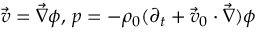Convert formula to latex. <formula><loc_0><loc_0><loc_500><loc_500>\vec { v } = \vec { \nabla } \phi , \, p = - \rho _ { 0 } ( \partial _ { t } + \vec { v } _ { 0 } \cdot \vec { \nabla } ) \phi</formula> 